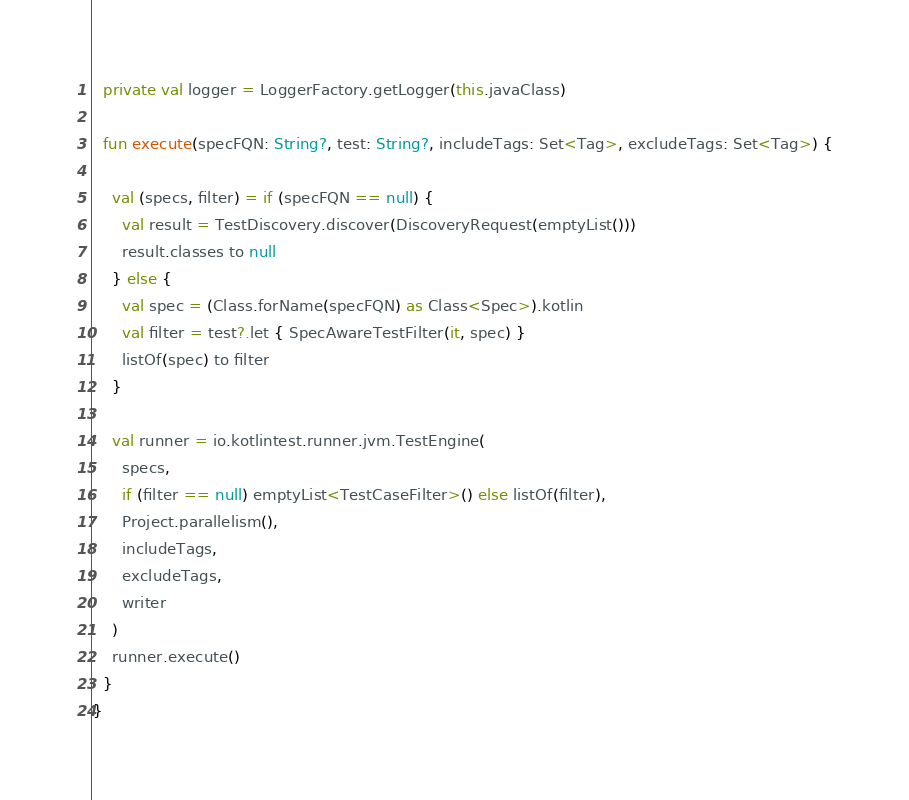<code> <loc_0><loc_0><loc_500><loc_500><_Kotlin_>
  private val logger = LoggerFactory.getLogger(this.javaClass)

  fun execute(specFQN: String?, test: String?, includeTags: Set<Tag>, excludeTags: Set<Tag>) {

    val (specs, filter) = if (specFQN == null) {
      val result = TestDiscovery.discover(DiscoveryRequest(emptyList()))
      result.classes to null
    } else {
      val spec = (Class.forName(specFQN) as Class<Spec>).kotlin
      val filter = test?.let { SpecAwareTestFilter(it, spec) }
      listOf(spec) to filter
    }

    val runner = io.kotlintest.runner.jvm.TestEngine(
      specs,
      if (filter == null) emptyList<TestCaseFilter>() else listOf(filter),
      Project.parallelism(),
      includeTags,
      excludeTags,
      writer
    )
    runner.execute()
  }
}
</code> 